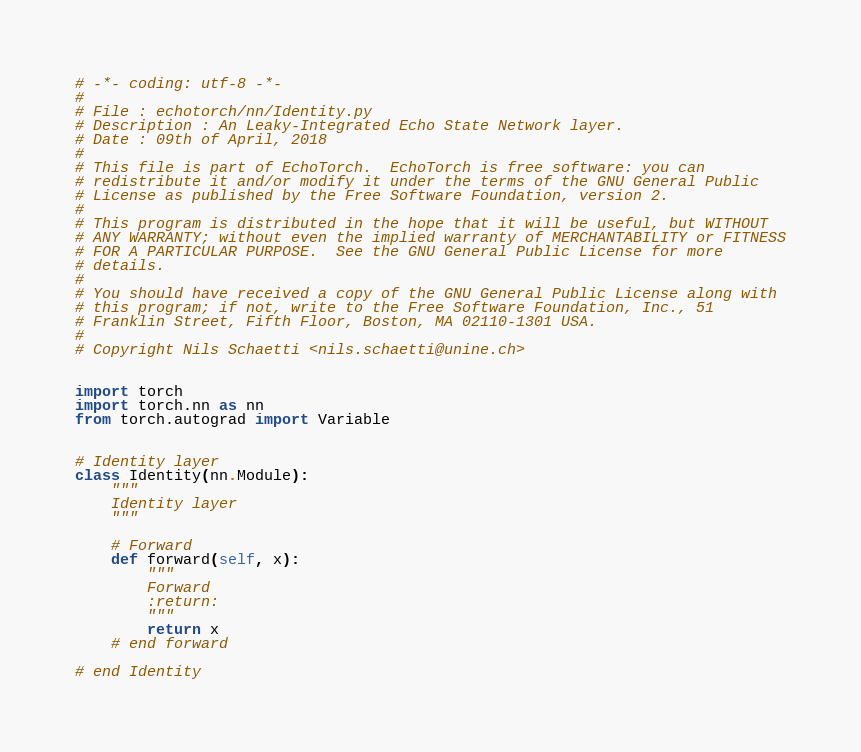Convert code to text. <code><loc_0><loc_0><loc_500><loc_500><_Python_># -*- coding: utf-8 -*-
#
# File : echotorch/nn/Identity.py
# Description : An Leaky-Integrated Echo State Network layer.
# Date : 09th of April, 2018
#
# This file is part of EchoTorch.  EchoTorch is free software: you can
# redistribute it and/or modify it under the terms of the GNU General Public
# License as published by the Free Software Foundation, version 2.
#
# This program is distributed in the hope that it will be useful, but WITHOUT
# ANY WARRANTY; without even the implied warranty of MERCHANTABILITY or FITNESS
# FOR A PARTICULAR PURPOSE.  See the GNU General Public License for more
# details.
#
# You should have received a copy of the GNU General Public License along with
# this program; if not, write to the Free Software Foundation, Inc., 51
# Franklin Street, Fifth Floor, Boston, MA 02110-1301 USA.
#
# Copyright Nils Schaetti <nils.schaetti@unine.ch>


import torch
import torch.nn as nn
from torch.autograd import Variable


# Identity layer
class Identity(nn.Module):
    """
    Identity layer
    """

    # Forward
    def forward(self, x):
        """
        Forward
        :return:
        """
        return x
    # end forward

# end Identity
</code> 